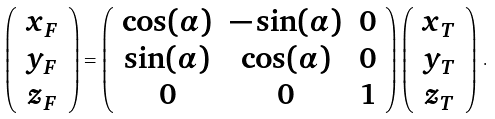<formula> <loc_0><loc_0><loc_500><loc_500>\left ( \begin{array} { c } x _ { F } \\ y _ { F } \\ z _ { F } \end{array} \right ) = \left ( \begin{array} { c c c } \cos ( \alpha ) & - \sin ( \alpha ) & 0 \\ \sin ( \alpha ) & \cos ( \alpha ) & 0 \\ 0 & 0 & 1 \end{array} \right ) \left ( \begin{array} { c } x _ { T } \\ y _ { T } \\ z _ { T } \end{array} \right ) \, .</formula> 